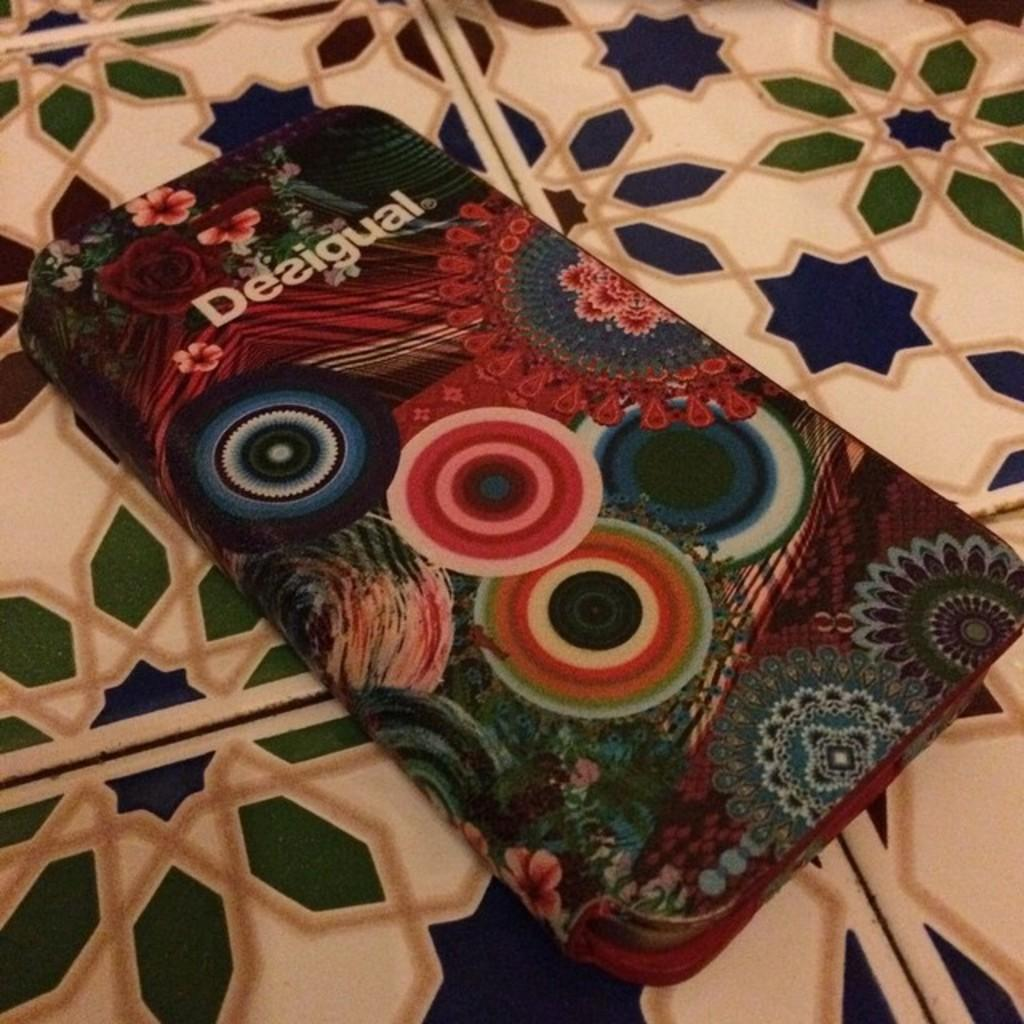What is present in the image? There is a box in the image. Can you describe the appearance of the box? The box has designs on it. Is there any text on the box? Yes, there is writing on the box. What type of neck accessory is hanging from the box in the image? There is no neck accessory present in the image; it only features a box with designs and writing. 